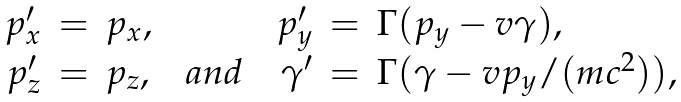Convert formula to latex. <formula><loc_0><loc_0><loc_500><loc_500>\begin{array} { r c l c c c r c l } p _ { x } ^ { \prime } & = & p _ { x } , & & & & p _ { y } ^ { \prime } & = & \Gamma ( p _ { y } - v \gamma ) , \\ p _ { z } ^ { \prime } & = & p _ { z } , & & a n d & & \gamma ^ { \prime } & = & \Gamma ( \gamma - v p _ { y } / ( m c ^ { 2 } ) ) , \end{array}</formula> 